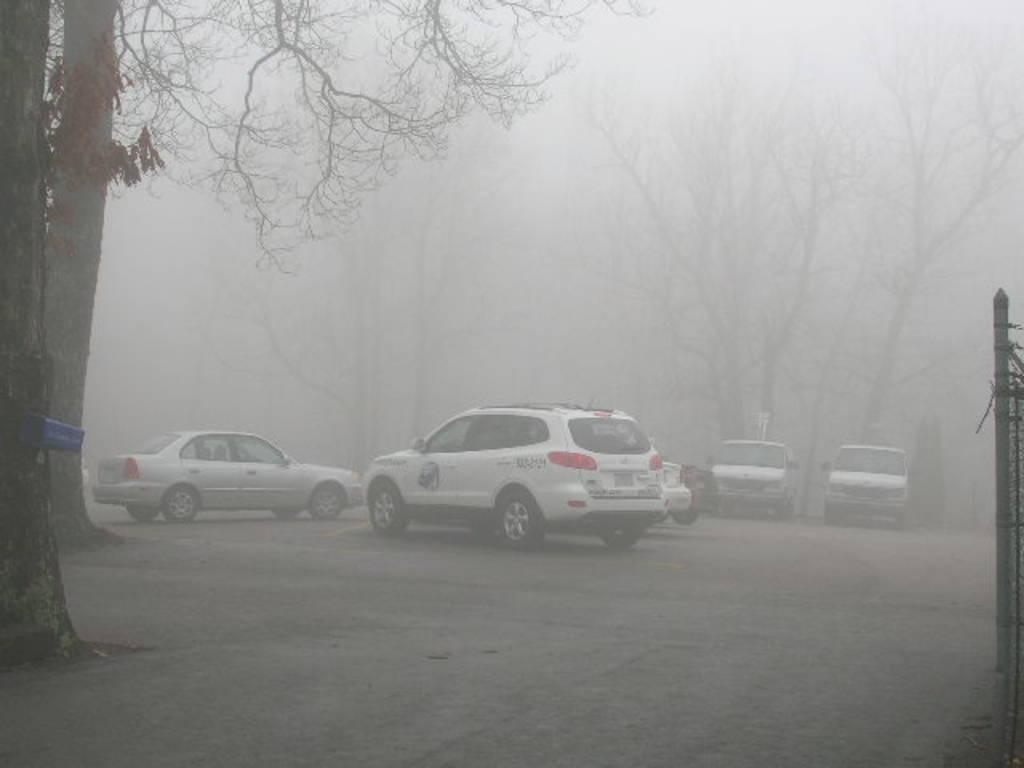What type of vehicles can be seen in the image? There are cars on the ground in the image. What natural elements are present in the image? There are trees and plants in the image. How is the visibility in the image affected? The entire scene is covered in fog. Where is the hook located in the image? There is no hook present in the image. Is there a battle taking place in the image? There is no battle depicted in the image. 